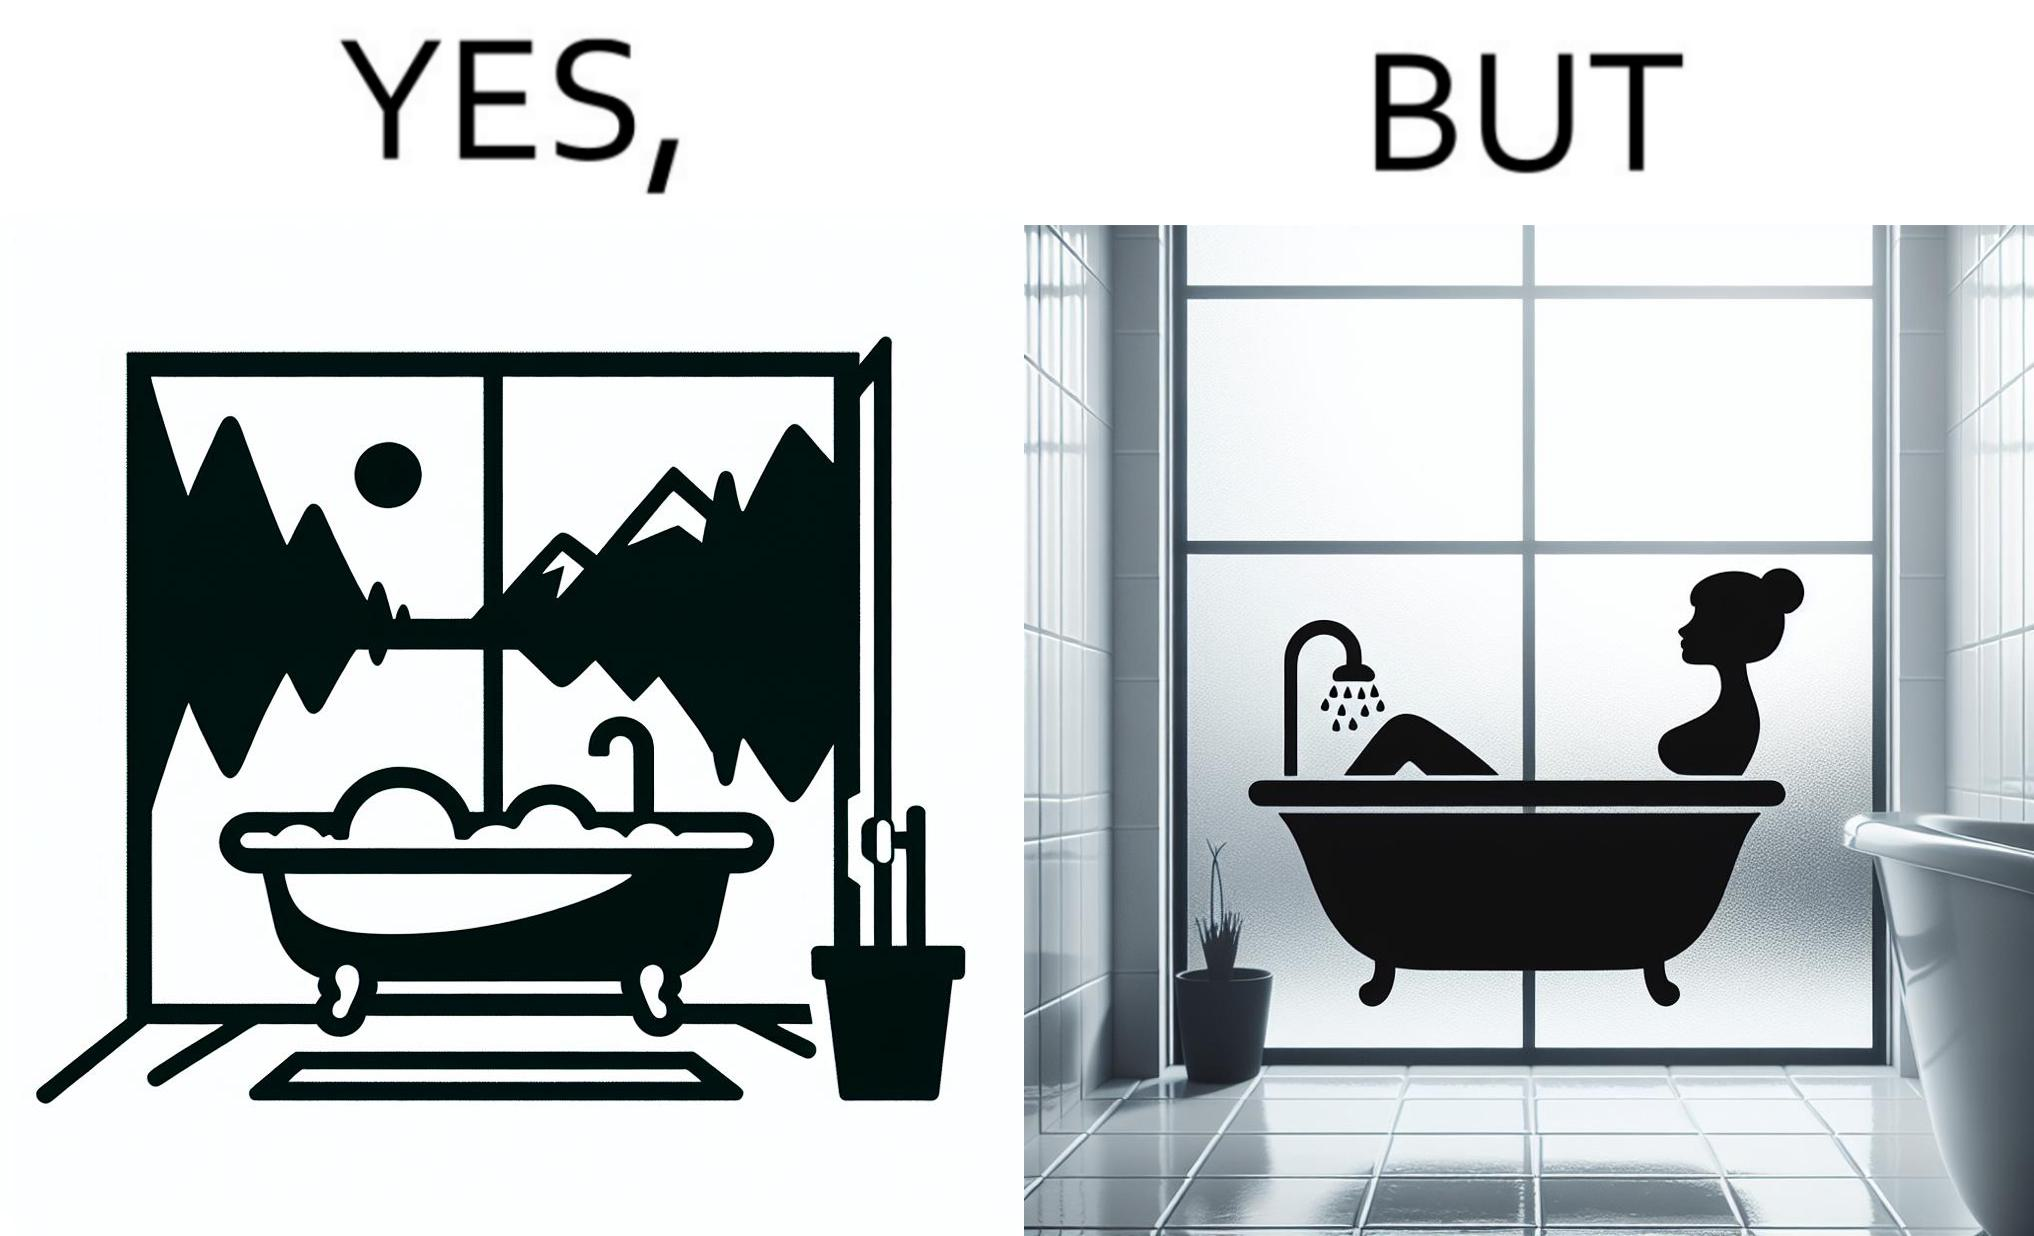What is the satirical meaning behind this image? The image is ironical, as a bathtub near a window having a very scenic view, becomes misty when someone is bathing, thus making the scenic view blurry. 